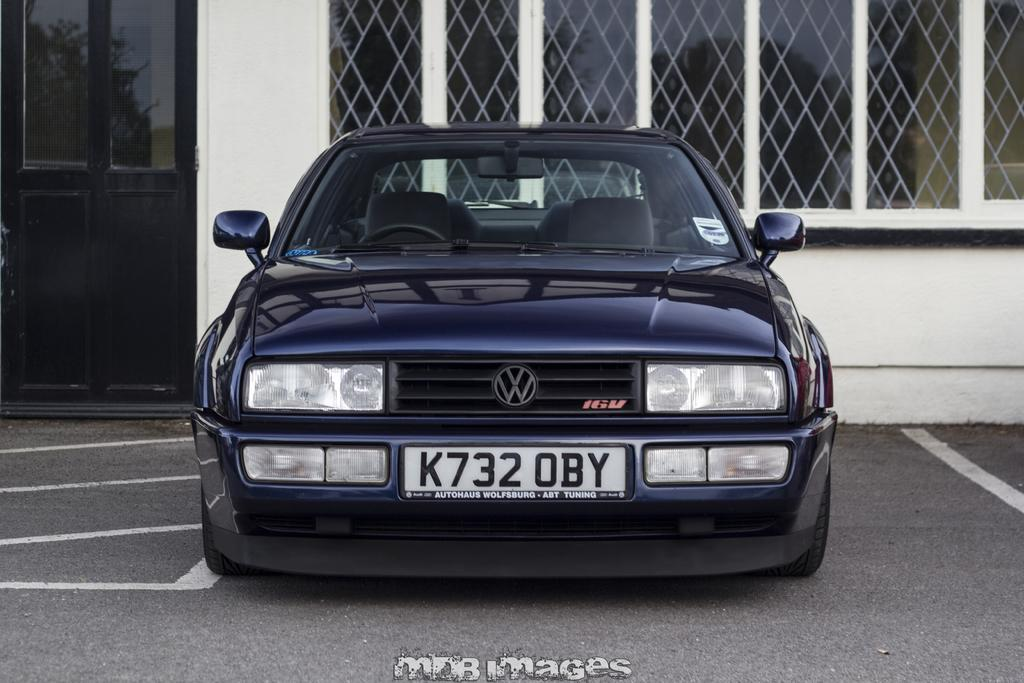What is the color of the wall in the image? There is a white-colored wall in the image. What type of openings can be seen in the image? There are windows in the image. What type of access points can be seen in the image? There are doors in the image. What type of vehicle is visible in the image? There is a blue-colored car in the image. What type of stocking is hanging near the windows in the image? There is no stocking present in the image. What type of stove is visible in the image? There is no stove present in the image. 